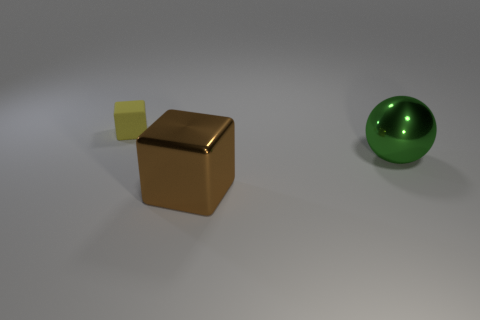Are there any purple rubber cubes that have the same size as the green ball? No, there are no purple rubber cubes present. The image only contains a brown cube, a green sphere, and a smaller yellow cube. 